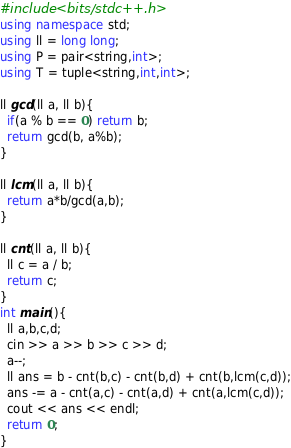<code> <loc_0><loc_0><loc_500><loc_500><_C++_>#include <bits/stdc++.h>
using namespace std;
using ll = long long;
using P = pair<string,int>;
using T = tuple<string,int,int>;

ll gcd(ll a, ll b){
  if(a % b == 0) return b;
  return gcd(b, a%b);
}

ll lcm(ll a, ll b){
  return a*b/gcd(a,b);
}

ll cnt(ll a, ll b){
  ll c = a / b;
  return c;
}
int main(){
  ll a,b,c,d;
  cin >> a >> b >> c >> d;
  a--;
  ll ans = b - cnt(b,c) - cnt(b,d) + cnt(b,lcm(c,d));
  ans -= a - cnt(a,c) - cnt(a,d) + cnt(a,lcm(c,d));
  cout << ans << endl;
  return 0;
}</code> 